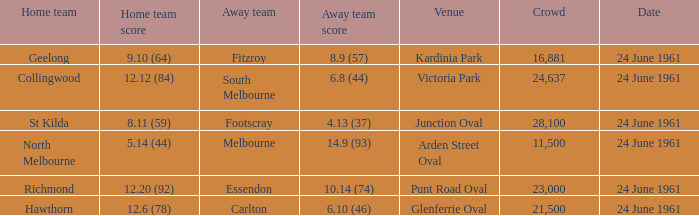Who was the home team that scored 12.6 (78)? Hawthorn. 